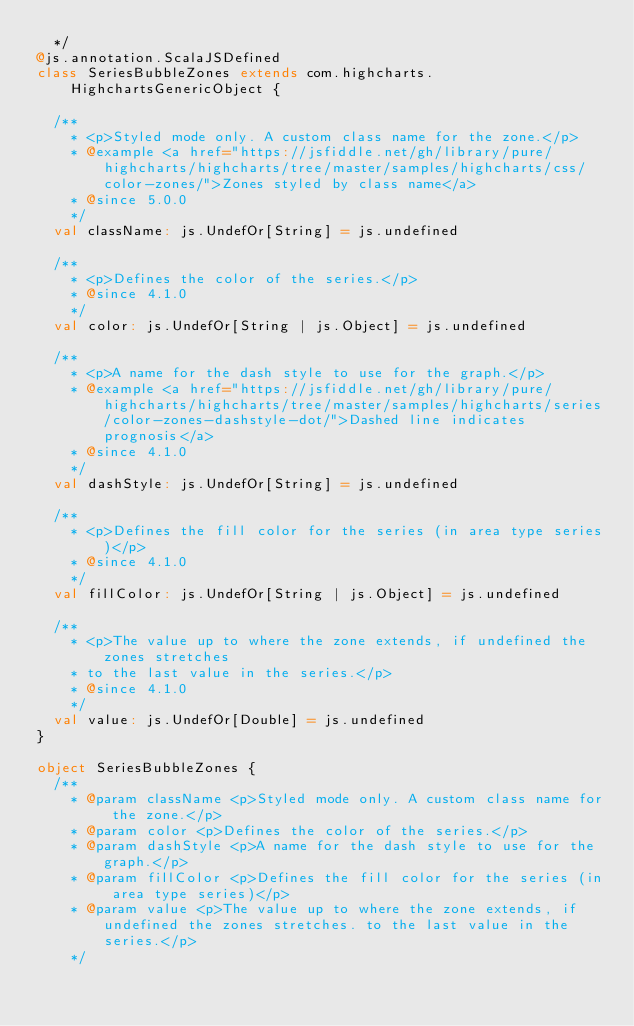Convert code to text. <code><loc_0><loc_0><loc_500><loc_500><_Scala_>  */
@js.annotation.ScalaJSDefined
class SeriesBubbleZones extends com.highcharts.HighchartsGenericObject {

  /**
    * <p>Styled mode only. A custom class name for the zone.</p>
    * @example <a href="https://jsfiddle.net/gh/library/pure/highcharts/highcharts/tree/master/samples/highcharts/css/color-zones/">Zones styled by class name</a>
    * @since 5.0.0
    */
  val className: js.UndefOr[String] = js.undefined

  /**
    * <p>Defines the color of the series.</p>
    * @since 4.1.0
    */
  val color: js.UndefOr[String | js.Object] = js.undefined

  /**
    * <p>A name for the dash style to use for the graph.</p>
    * @example <a href="https://jsfiddle.net/gh/library/pure/highcharts/highcharts/tree/master/samples/highcharts/series/color-zones-dashstyle-dot/">Dashed line indicates prognosis</a>
    * @since 4.1.0
    */
  val dashStyle: js.UndefOr[String] = js.undefined

  /**
    * <p>Defines the fill color for the series (in area type series)</p>
    * @since 4.1.0
    */
  val fillColor: js.UndefOr[String | js.Object] = js.undefined

  /**
    * <p>The value up to where the zone extends, if undefined the zones stretches
    * to the last value in the series.</p>
    * @since 4.1.0
    */
  val value: js.UndefOr[Double] = js.undefined
}

object SeriesBubbleZones {
  /**
    * @param className <p>Styled mode only. A custom class name for the zone.</p>
    * @param color <p>Defines the color of the series.</p>
    * @param dashStyle <p>A name for the dash style to use for the graph.</p>
    * @param fillColor <p>Defines the fill color for the series (in area type series)</p>
    * @param value <p>The value up to where the zone extends, if undefined the zones stretches. to the last value in the series.</p>
    */</code> 